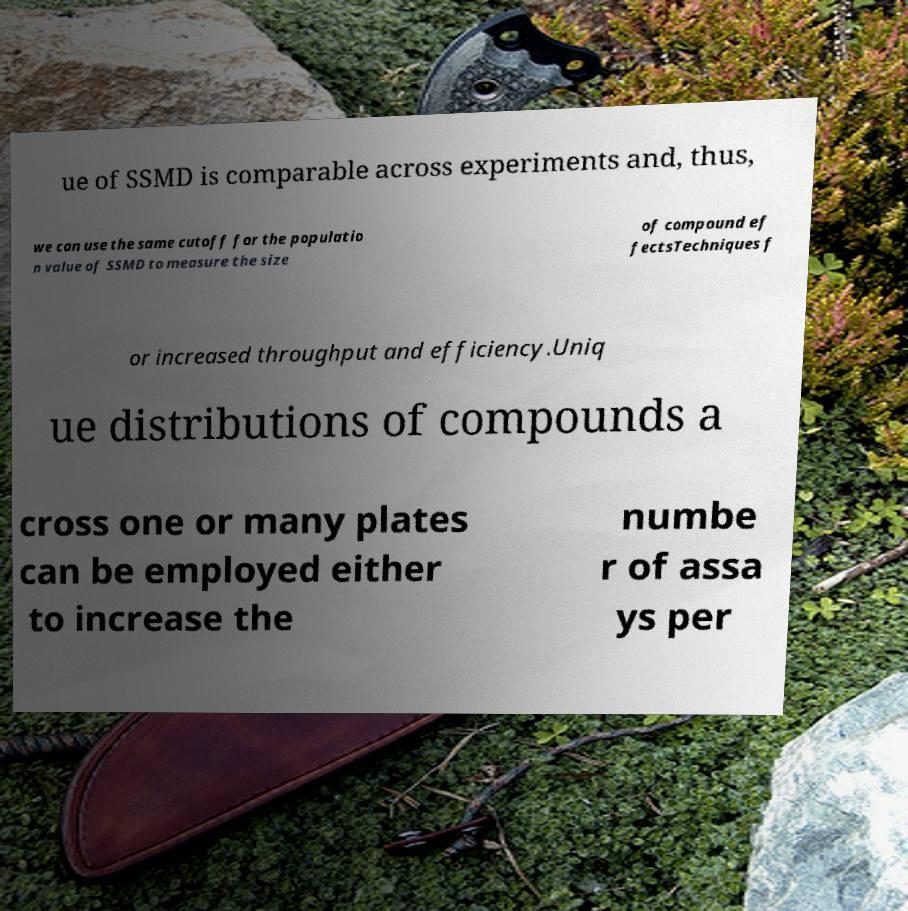Could you assist in decoding the text presented in this image and type it out clearly? ue of SSMD is comparable across experiments and, thus, we can use the same cutoff for the populatio n value of SSMD to measure the size of compound ef fectsTechniques f or increased throughput and efficiency.Uniq ue distributions of compounds a cross one or many plates can be employed either to increase the numbe r of assa ys per 